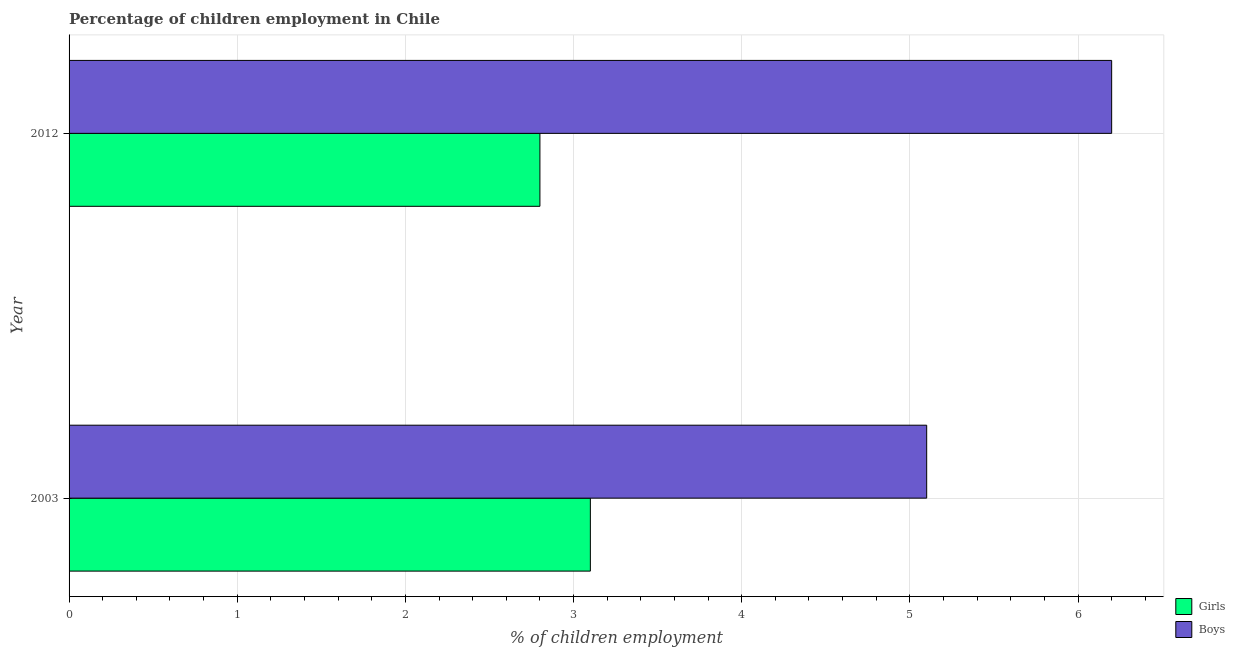How many groups of bars are there?
Offer a very short reply. 2. Are the number of bars on each tick of the Y-axis equal?
Ensure brevity in your answer.  Yes. What is the label of the 1st group of bars from the top?
Keep it short and to the point. 2012. Across all years, what is the maximum percentage of employed girls?
Your answer should be very brief. 3.1. In which year was the percentage of employed girls maximum?
Ensure brevity in your answer.  2003. What is the average percentage of employed girls per year?
Keep it short and to the point. 2.95. In the year 2012, what is the difference between the percentage of employed girls and percentage of employed boys?
Keep it short and to the point. -3.4. What is the ratio of the percentage of employed boys in 2003 to that in 2012?
Ensure brevity in your answer.  0.82. Is the percentage of employed boys in 2003 less than that in 2012?
Provide a succinct answer. Yes. Is the difference between the percentage of employed girls in 2003 and 2012 greater than the difference between the percentage of employed boys in 2003 and 2012?
Offer a very short reply. Yes. What does the 2nd bar from the top in 2003 represents?
Offer a terse response. Girls. What does the 1st bar from the bottom in 2012 represents?
Offer a terse response. Girls. How many bars are there?
Provide a short and direct response. 4. How many years are there in the graph?
Offer a terse response. 2. What is the difference between two consecutive major ticks on the X-axis?
Offer a terse response. 1. Are the values on the major ticks of X-axis written in scientific E-notation?
Offer a very short reply. No. Does the graph contain grids?
Offer a very short reply. Yes. Where does the legend appear in the graph?
Provide a succinct answer. Bottom right. What is the title of the graph?
Offer a very short reply. Percentage of children employment in Chile. What is the label or title of the X-axis?
Keep it short and to the point. % of children employment. What is the % of children employment in Boys in 2003?
Your response must be concise. 5.1. Across all years, what is the maximum % of children employment of Girls?
Provide a short and direct response. 3.1. Across all years, what is the minimum % of children employment in Girls?
Make the answer very short. 2.8. What is the total % of children employment of Girls in the graph?
Your answer should be very brief. 5.9. What is the total % of children employment of Boys in the graph?
Provide a succinct answer. 11.3. What is the difference between the % of children employment of Girls in 2003 and that in 2012?
Make the answer very short. 0.3. What is the difference between the % of children employment in Boys in 2003 and that in 2012?
Provide a short and direct response. -1.1. What is the difference between the % of children employment in Girls in 2003 and the % of children employment in Boys in 2012?
Keep it short and to the point. -3.1. What is the average % of children employment in Girls per year?
Offer a terse response. 2.95. What is the average % of children employment of Boys per year?
Offer a very short reply. 5.65. What is the ratio of the % of children employment of Girls in 2003 to that in 2012?
Offer a very short reply. 1.11. What is the ratio of the % of children employment of Boys in 2003 to that in 2012?
Provide a succinct answer. 0.82. 